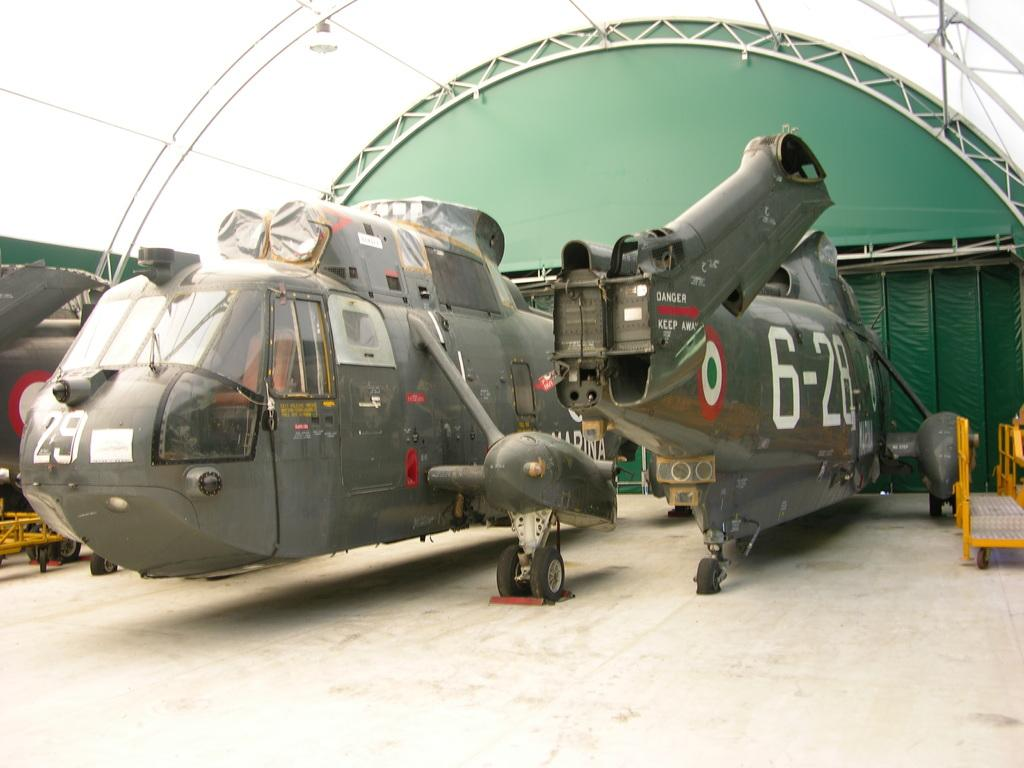Provide a one-sentence caption for the provided image. A jet with the numbers 6-28 is in the hangar. 